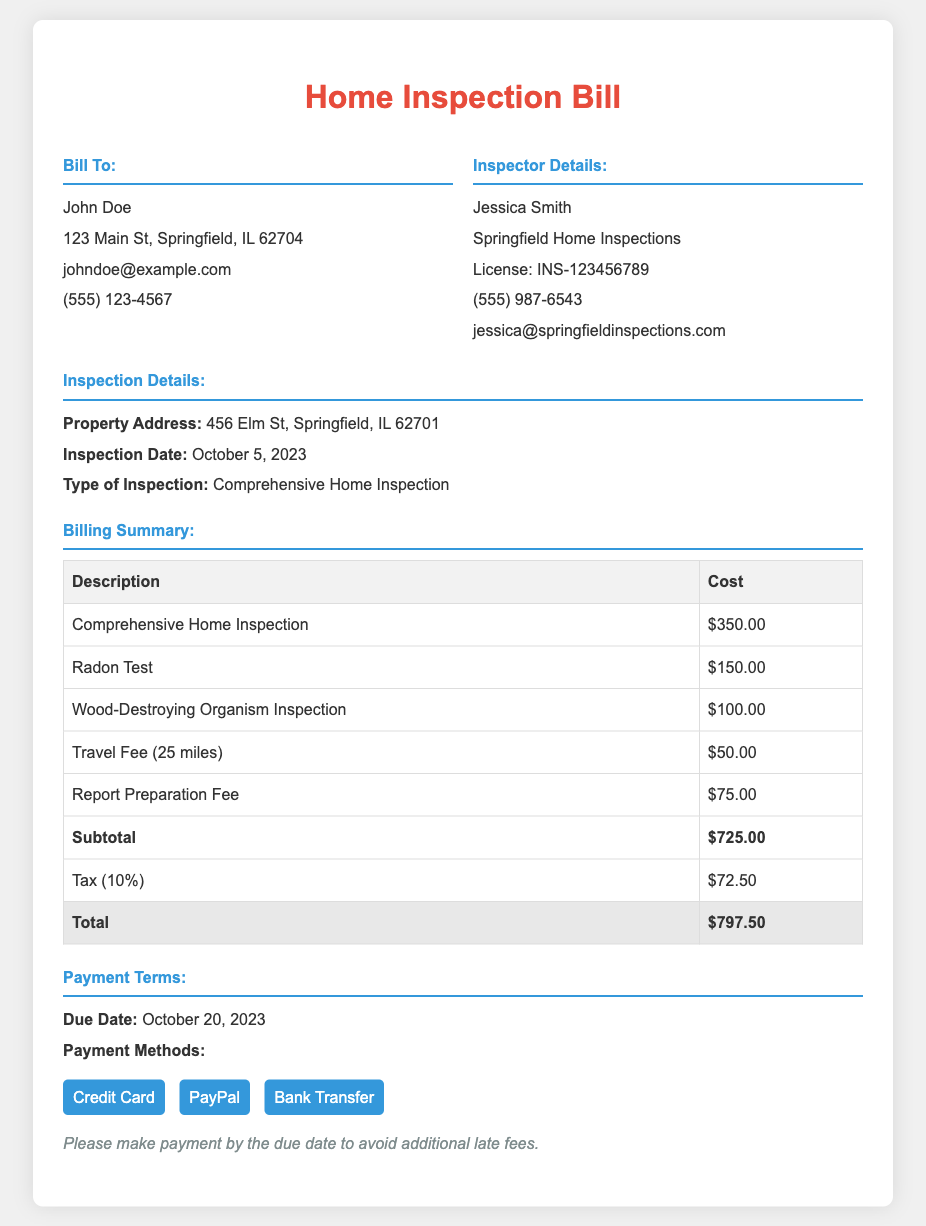What is the total amount due? The total amount due is listed at the bottom of the billing summary table, which is $797.50.
Answer: $797.50 Who conducted the home inspection? The inspector's name is mentioned in the "Inspector Details" section, which identifies Jessica Smith as the inspector.
Answer: Jessica Smith What is the due date for payment? The due date for payment is specified in the "Payment Terms" section, which states October 20, 2023.
Answer: October 20, 2023 How much was charged for the radon test? The cost associated with the radon test is provided in the "Billing Summary" table, where it shows $150.00.
Answer: $150.00 What is the tax percentage applied? The tax percentage is indicated in the billing summary, listed as 10%.
Answer: 10% How many miles was the travel fee calculated for? The travel fee section specifies that it was calculated for 25 miles.
Answer: 25 miles What type of inspection was conducted? The type of inspection is noted in the "Inspection Details" section, which states Comprehensive Home Inspection.
Answer: Comprehensive Home Inspection What is the subtotal before tax? The subtotal amount in the billing summary is provided before tax calculations, which is $725.00.
Answer: $725.00 